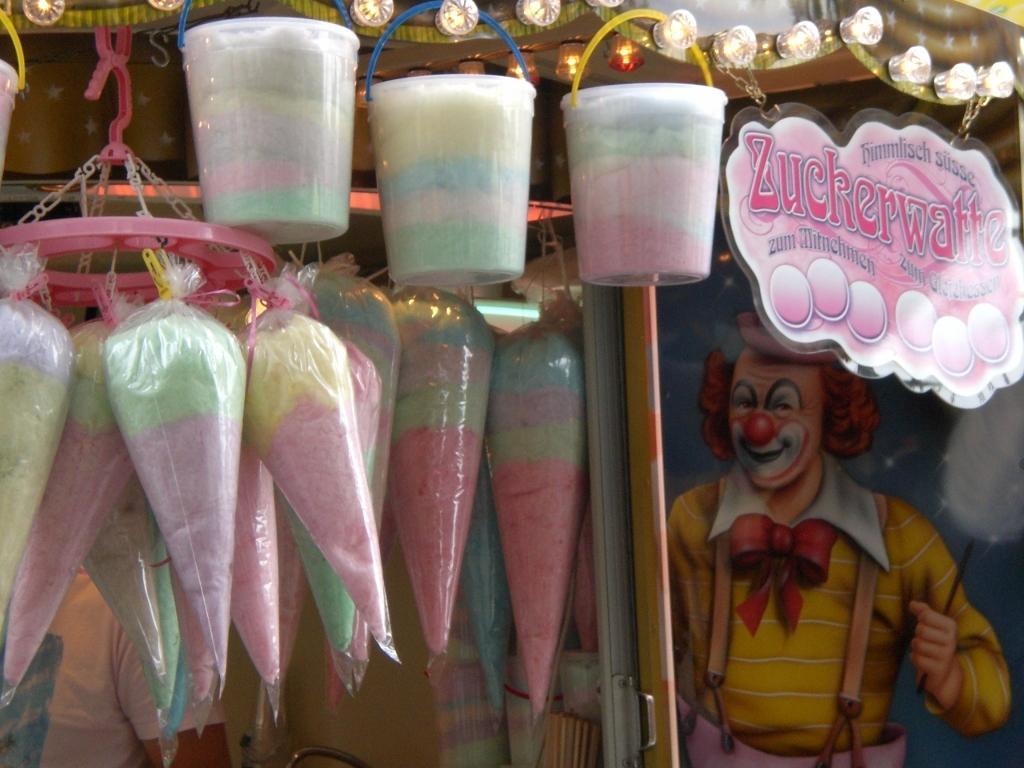Can you describe this image briefly? In this image I can see few candy in packets and packets. I can see a pink board and lights. Back I can see a joker painting on the wall. 